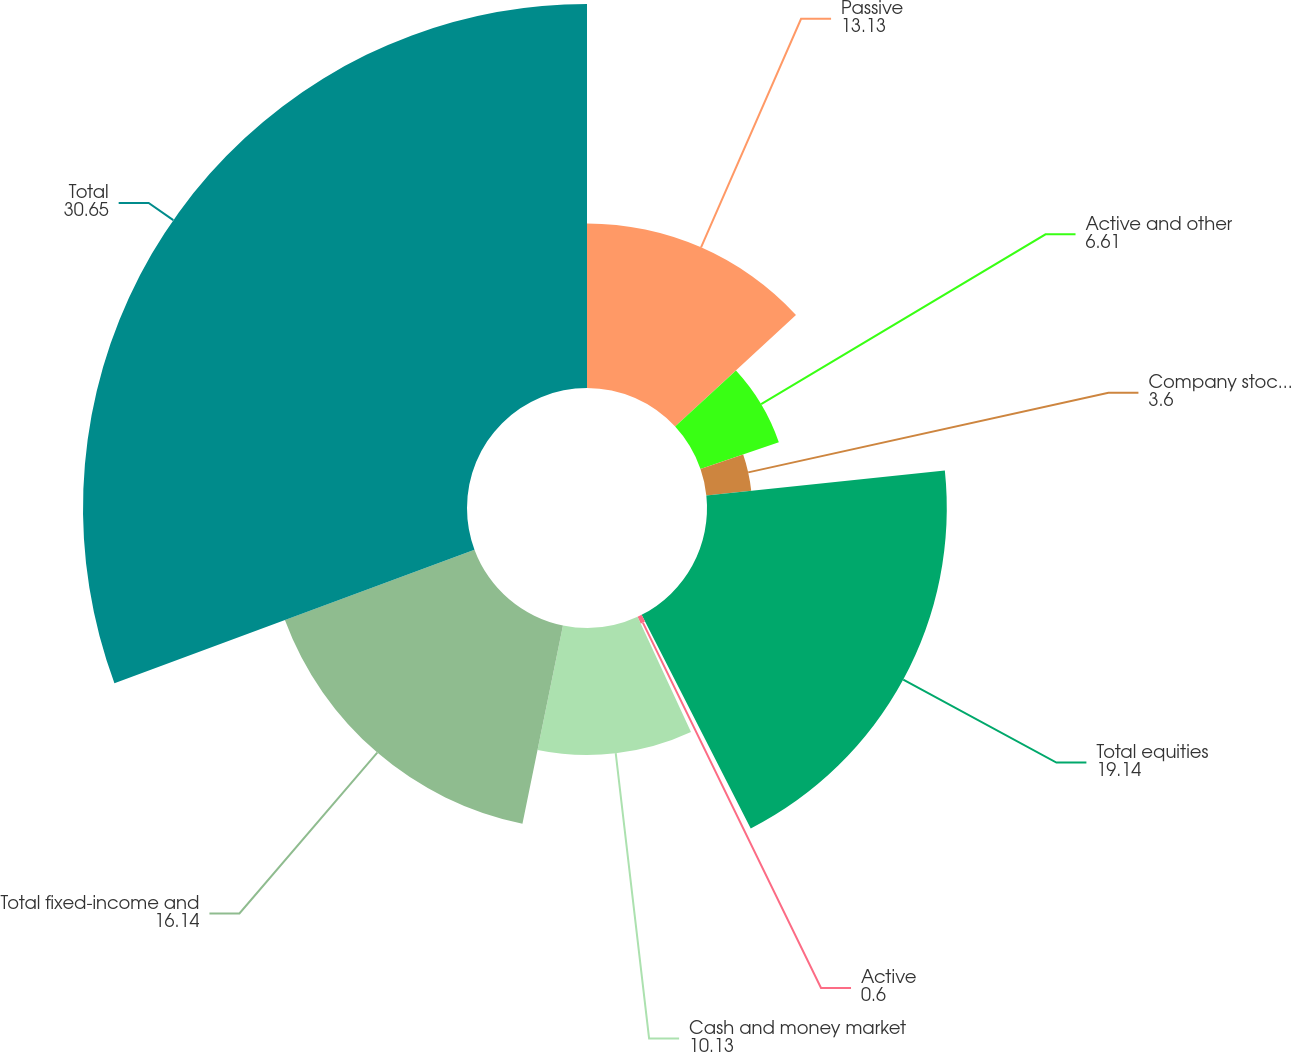<chart> <loc_0><loc_0><loc_500><loc_500><pie_chart><fcel>Passive<fcel>Active and other<fcel>Company stock/ESOP<fcel>Total equities<fcel>Active<fcel>Cash and money market<fcel>Total fixed-income and<fcel>Total<nl><fcel>13.13%<fcel>6.61%<fcel>3.6%<fcel>19.14%<fcel>0.6%<fcel>10.13%<fcel>16.14%<fcel>30.65%<nl></chart> 